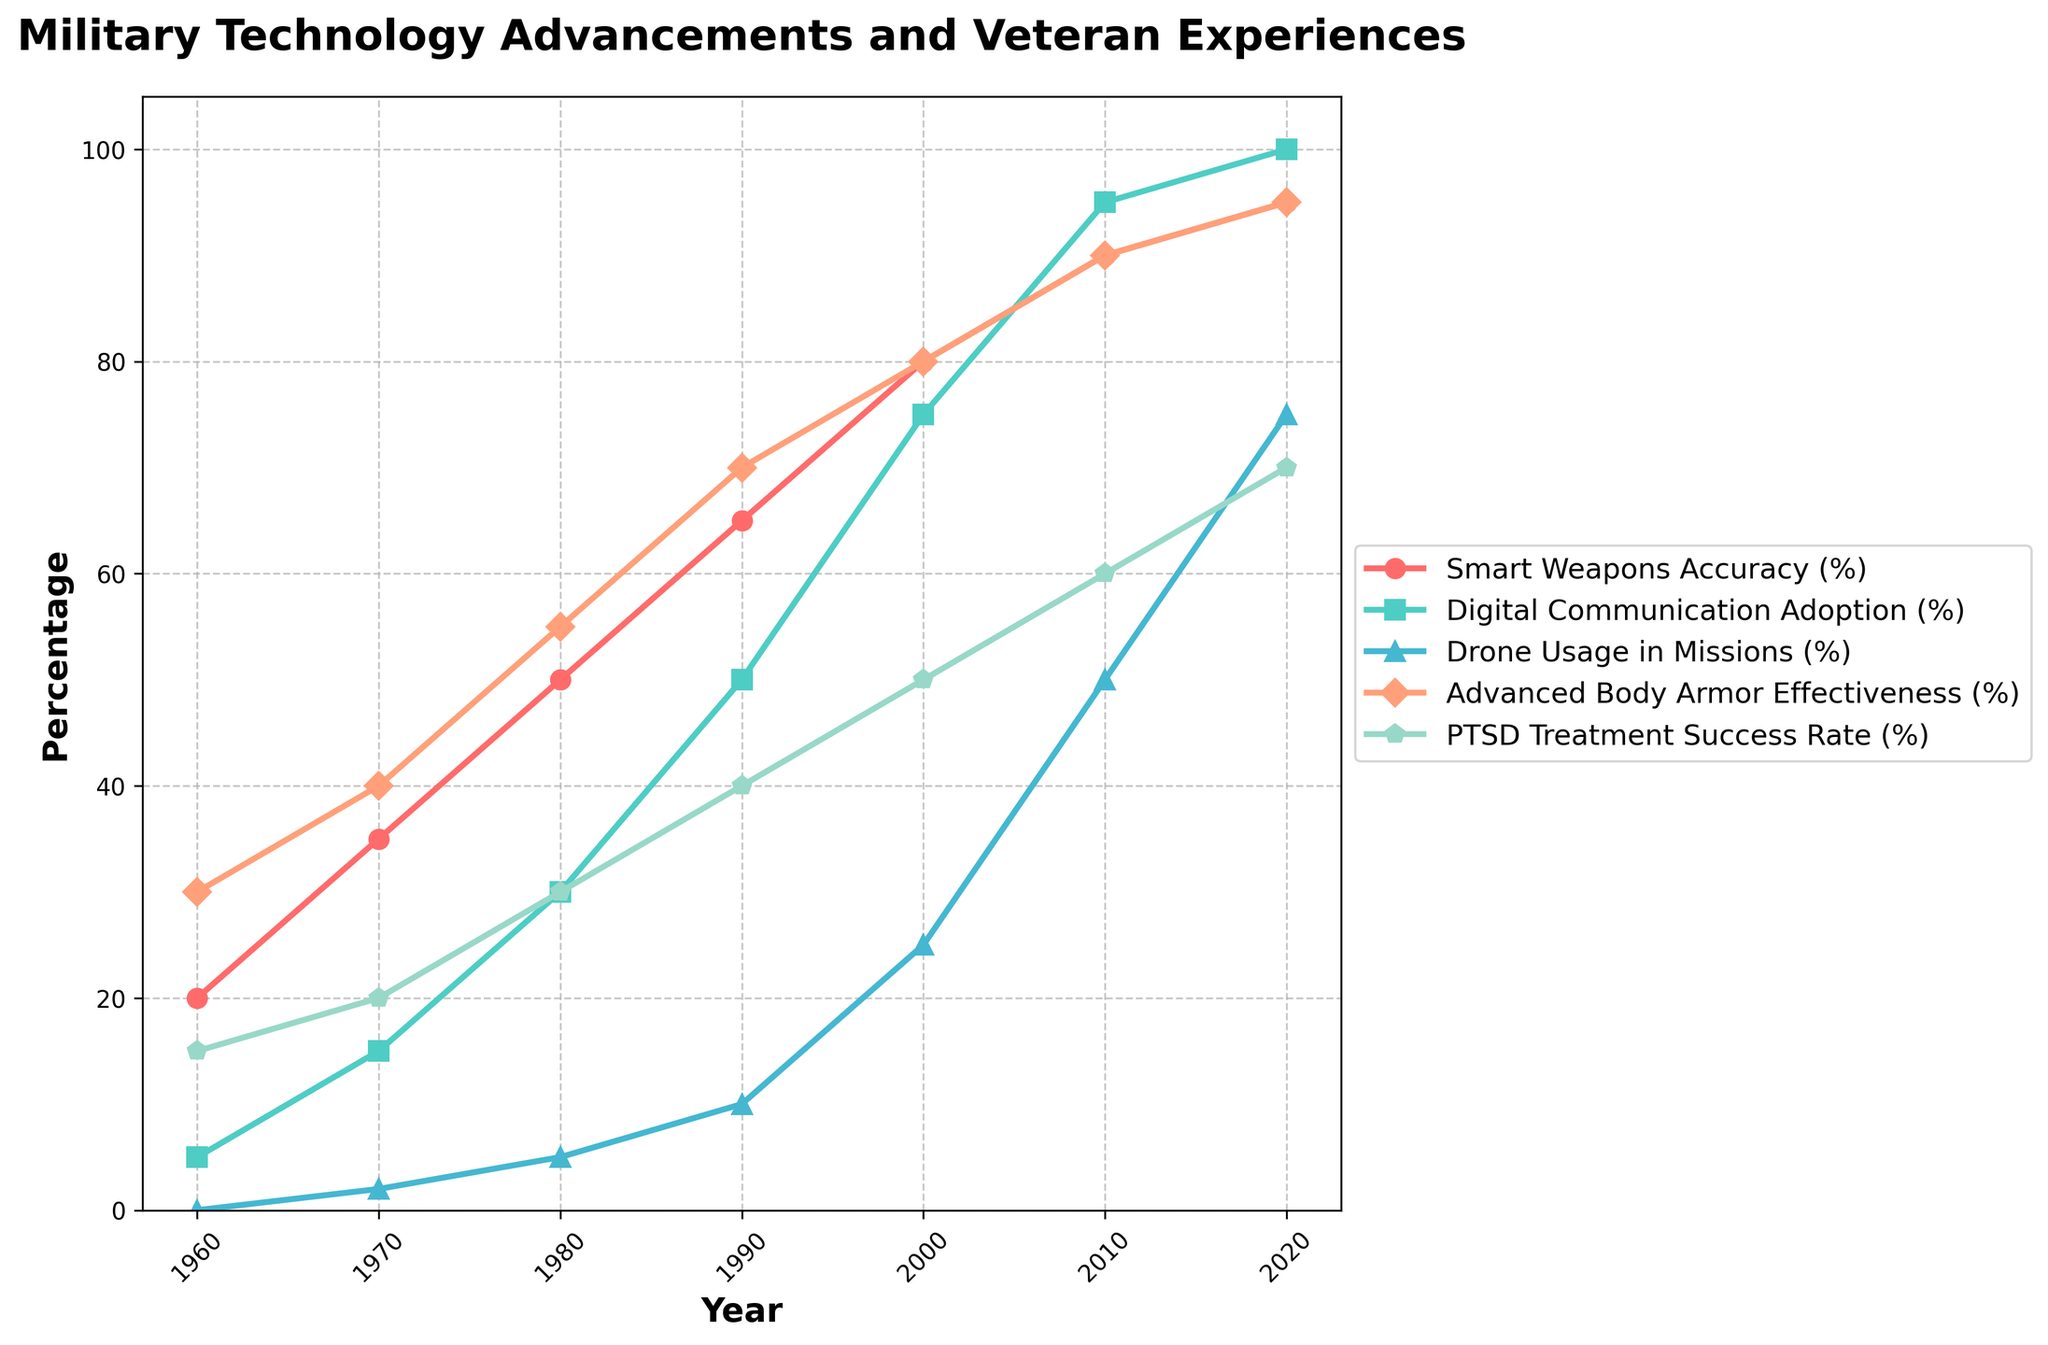What trend can we observe in the Smart Weapons Accuracy (%) over the decades? The Smart Weapons Accuracy (%) increases continuously from 20% in 1960 to 95% in 2020.
Answer: Continuous increase Between which decades did Digital Communication Adoption (%) see the highest growth, and what was its magnitude? The highest growth in Digital Communication Adoption (%) occurred between the 2000s and the 2010s, increasing from 75% to 95%. The growth magnitude was 20%.
Answer: 2000s to 2010s, 20% By how much did Drone Usage in Missions (%) increase from 1990 to 2020? Drone Usage in Missions (%) increased from 10% in 1990 to 75% in 2020. The increase was 75% - 10% = 65%.
Answer: 65% Compare the Advanced Body Armor Effectiveness (%) in 1960 to that in 2020. In 1960, Advanced Body Armor Effectiveness (%) was 30%, while in 2020, it was 95%. It is significantly higher in 2020 by 95% - 30% = 65%.
Answer: 65% higher in 2020 Which metric saw the largest improvement from 1960 to 2020? By comparing all metrics, the largest improvement was seen in Digital Communication Adoption (%), which increased from 5% to 100%, an improvement of 95%.
Answer: Digital Communication Adoption (%) Is the PTSD Treatment Success Rate (%) higher in 2000 or 2010, and by how much? The PTSD Treatment Success Rate (%) in 2000 was 50%, while in 2010 it was 60%. It is higher in 2010 by 60% - 50% = 10%.
Answer: 2010, 10% higher Looking at the line colors, which metric's trend is represented by the color red? The color red represents the trend for Smart Weapons Accuracy (%).
Answer: Smart Weapons Accuracy (%) Calculate the average increase per decade in Advanced Body Armor Effectiveness (%) from 1960 to 2020. The increase in Advanced Body Armor Effectiveness (%) from 1960 to 2020 is 95% - 30% = 65% over 6 decades. The average increase per decade is 65% / 6 ≈ 10.83%.
Answer: ≈ 10.83% What visual characteristic uniquely identifies the trend for Drone Usage in Missions (%) on the plot? The trend for Drone Usage in Missions (%) is uniquely identified by a green line with triangle markers.
Answer: Green line with triangle markers Compare the growth rates of Smart Weapons Accuracy (%) and PTSD Treatment Success Rate (%) from 1980 to 1990. Smart Weapons Accuracy (%) grew from 50% to 65% from 1980 to 1990, a growth rate of (65%-50%) / 10 years = 1.5% per year. PTSD Treatment Success Rate (%) grew from 30% to 40% in the same period, a growth rate of (40%-30%) / 10 years = 1% per year.
Answer: Smart Weapons Accuracy grew faster at 1.5% per year 